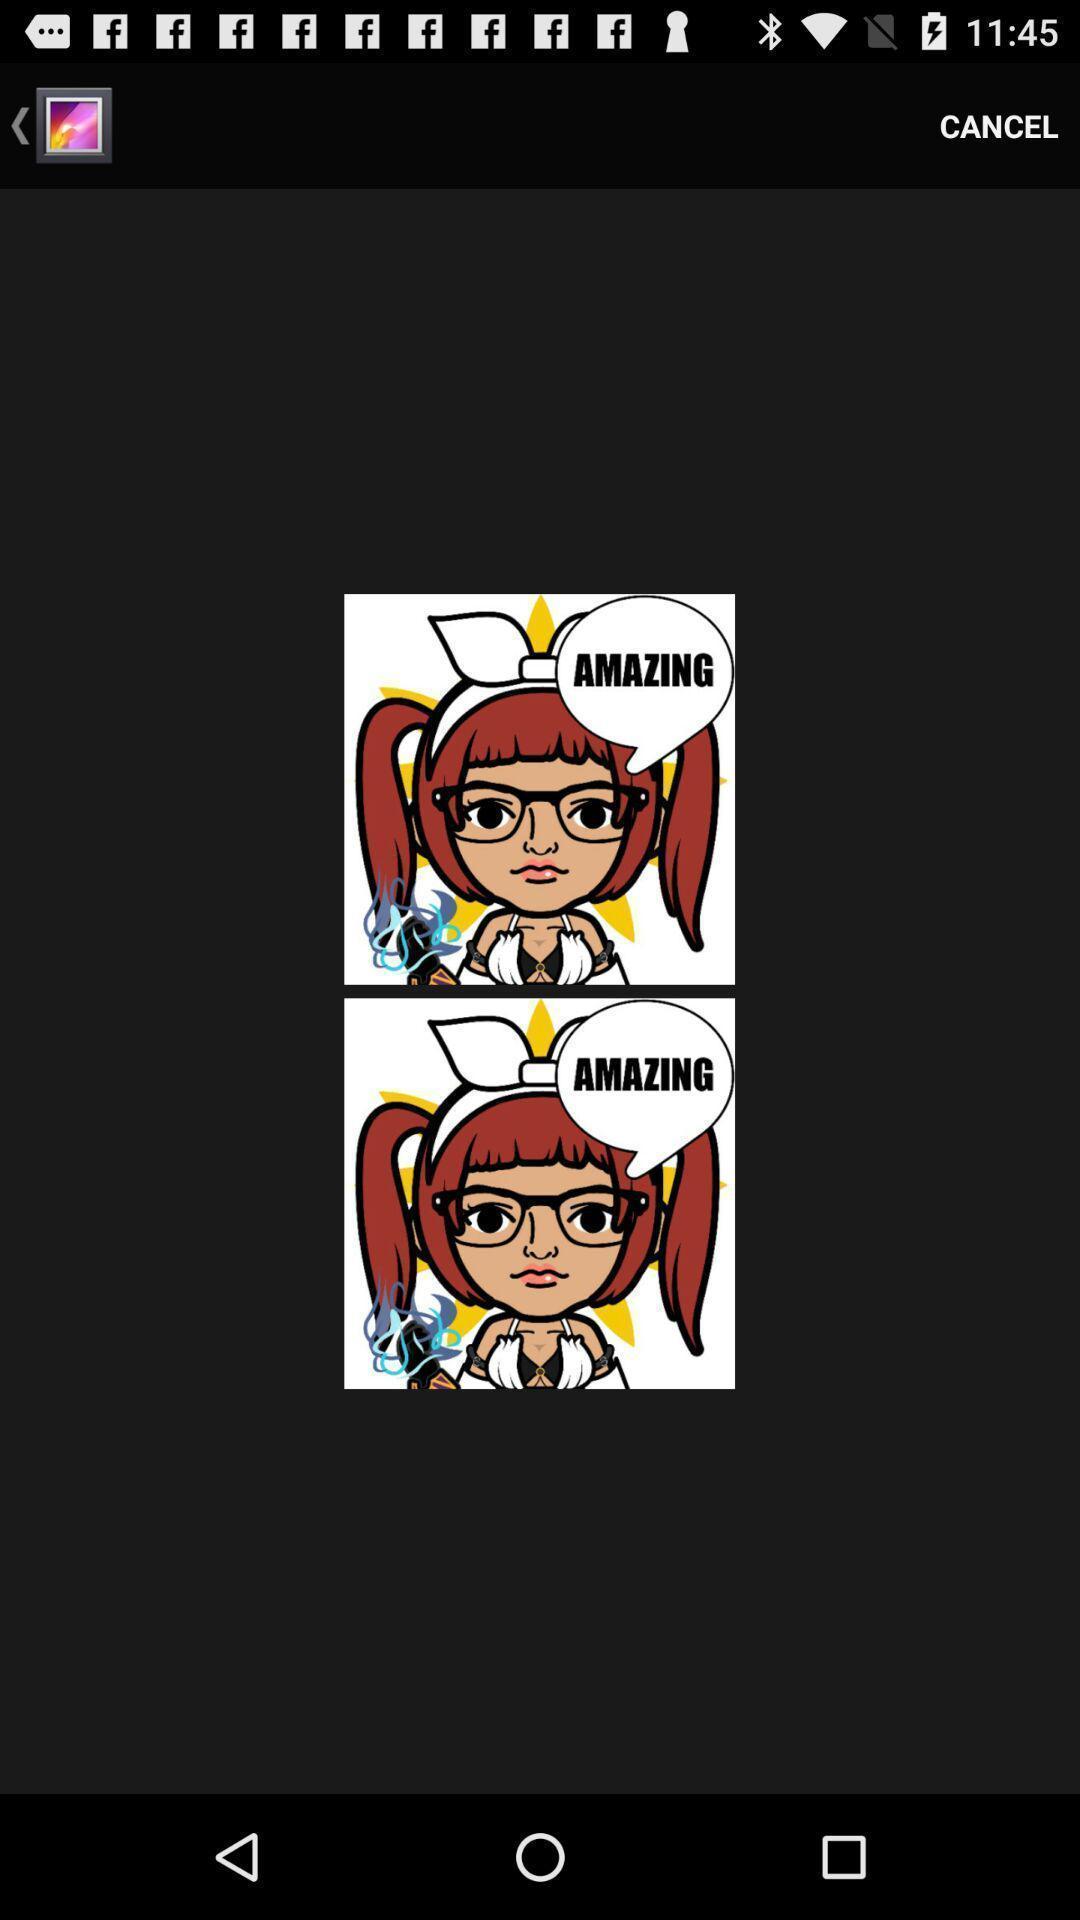Give me a summary of this screen capture. Page showing an image in a gallery. 